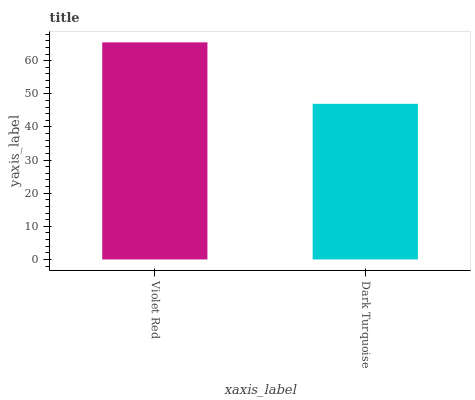Is Dark Turquoise the minimum?
Answer yes or no. Yes. Is Violet Red the maximum?
Answer yes or no. Yes. Is Dark Turquoise the maximum?
Answer yes or no. No. Is Violet Red greater than Dark Turquoise?
Answer yes or no. Yes. Is Dark Turquoise less than Violet Red?
Answer yes or no. Yes. Is Dark Turquoise greater than Violet Red?
Answer yes or no. No. Is Violet Red less than Dark Turquoise?
Answer yes or no. No. Is Violet Red the high median?
Answer yes or no. Yes. Is Dark Turquoise the low median?
Answer yes or no. Yes. Is Dark Turquoise the high median?
Answer yes or no. No. Is Violet Red the low median?
Answer yes or no. No. 